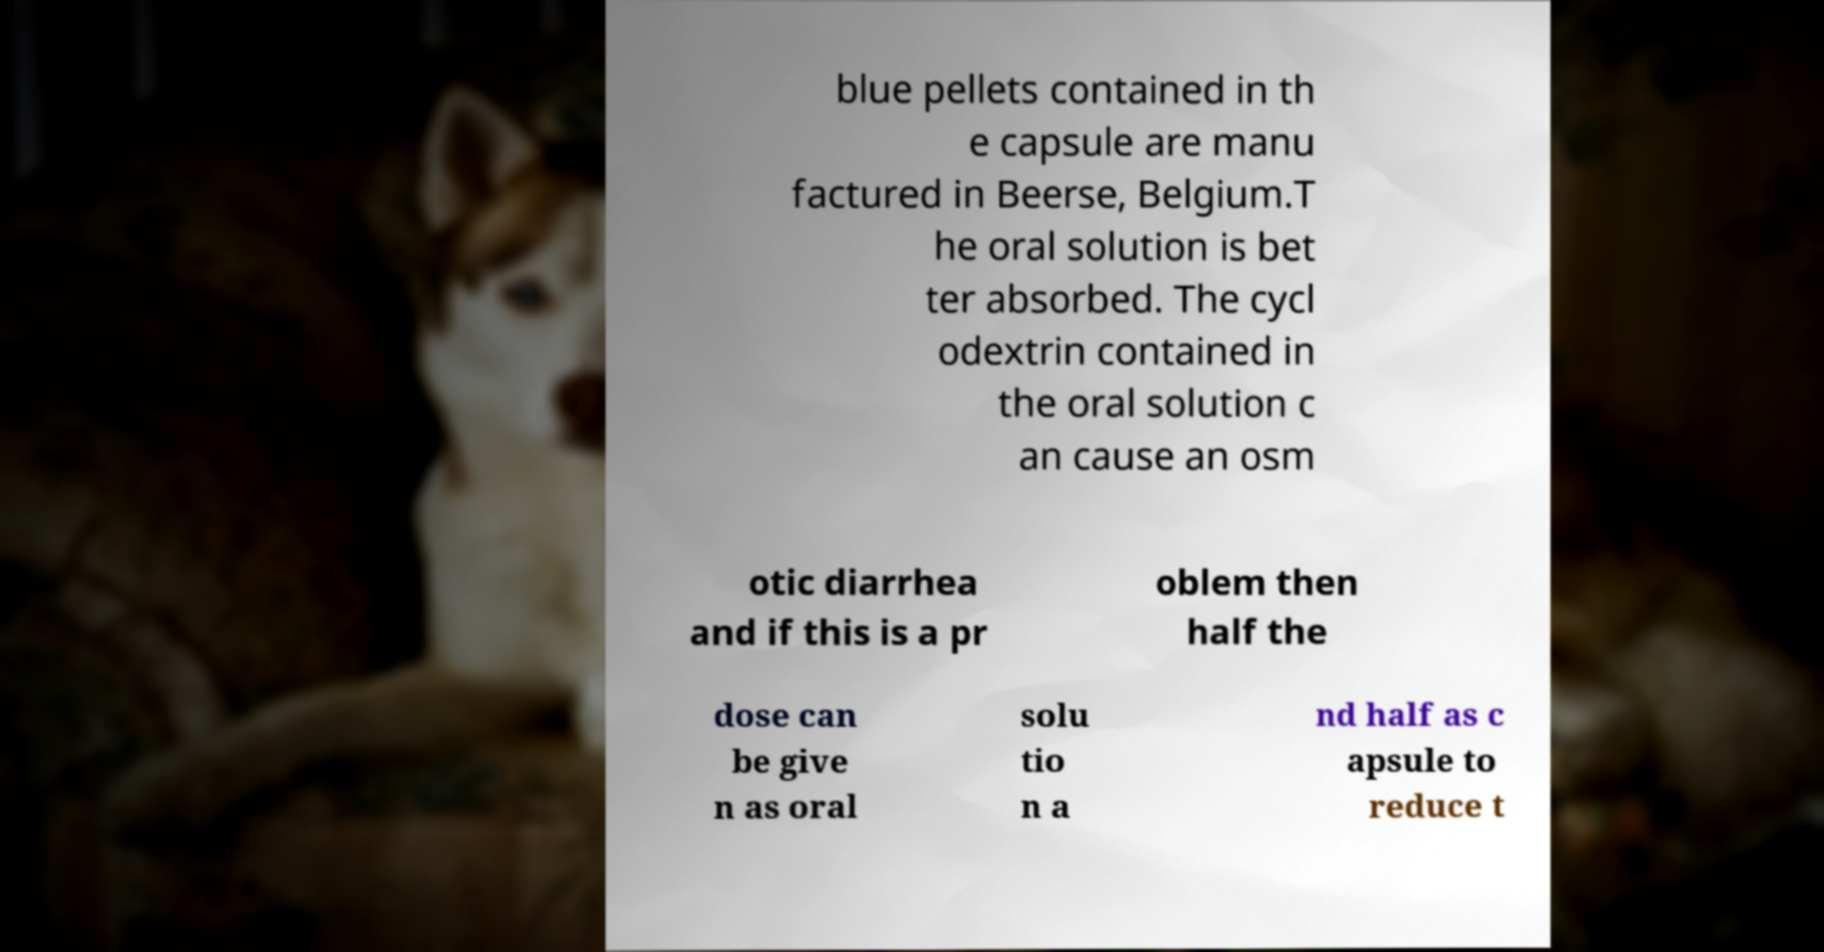There's text embedded in this image that I need extracted. Can you transcribe it verbatim? blue pellets contained in th e capsule are manu factured in Beerse, Belgium.T he oral solution is bet ter absorbed. The cycl odextrin contained in the oral solution c an cause an osm otic diarrhea and if this is a pr oblem then half the dose can be give n as oral solu tio n a nd half as c apsule to reduce t 